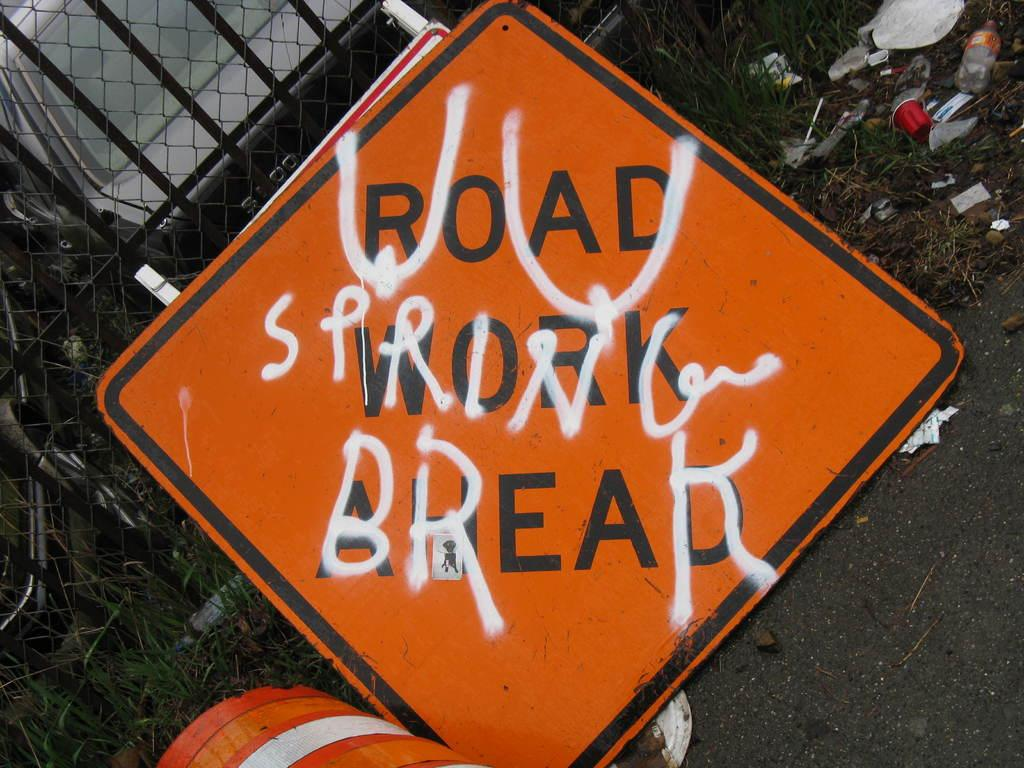What type of surface can be seen in the image? There is a road in the image. What type of vegetation is present in the image? There is grass in the image. What type of barrier is visible in the image? There is a fence in the image. What type of object is present in the image that can transport people or goods? There is a vehicle in the image. What message is conveyed by the board in the image? The board indicates that it is a trash area. What angle is the place shown in the image? The image does not depict a specific angle or perspective of a place; it shows a road, grass, a fence, a vehicle, and a board with text. What form does the trash take in the image? The image does not show any trash; it only indicates that it is a trash area with a board. 